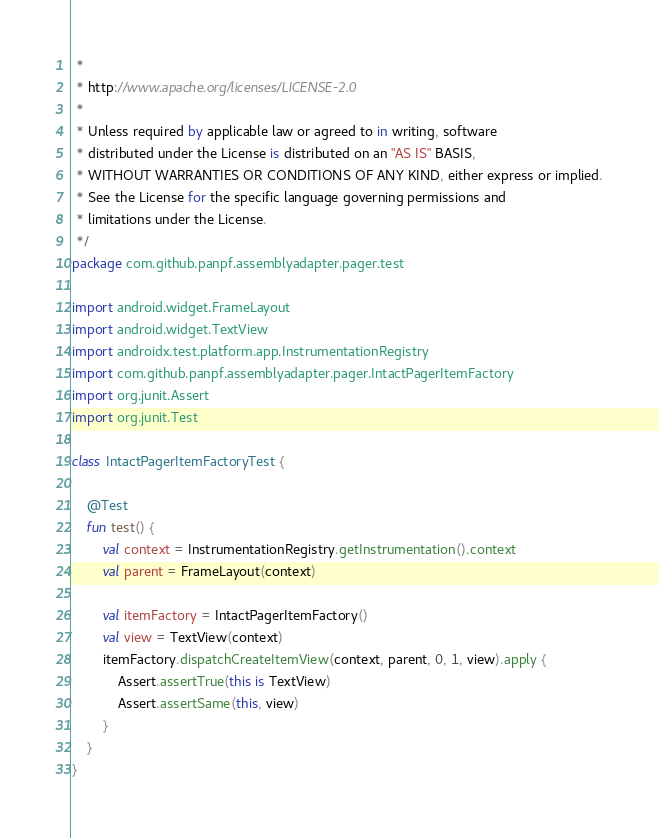Convert code to text. <code><loc_0><loc_0><loc_500><loc_500><_Kotlin_> *
 * http://www.apache.org/licenses/LICENSE-2.0
 *
 * Unless required by applicable law or agreed to in writing, software
 * distributed under the License is distributed on an "AS IS" BASIS,
 * WITHOUT WARRANTIES OR CONDITIONS OF ANY KIND, either express or implied.
 * See the License for the specific language governing permissions and
 * limitations under the License.
 */
package com.github.panpf.assemblyadapter.pager.test

import android.widget.FrameLayout
import android.widget.TextView
import androidx.test.platform.app.InstrumentationRegistry
import com.github.panpf.assemblyadapter.pager.IntactPagerItemFactory
import org.junit.Assert
import org.junit.Test

class IntactPagerItemFactoryTest {

    @Test
    fun test() {
        val context = InstrumentationRegistry.getInstrumentation().context
        val parent = FrameLayout(context)

        val itemFactory = IntactPagerItemFactory()
        val view = TextView(context)
        itemFactory.dispatchCreateItemView(context, parent, 0, 1, view).apply {
            Assert.assertTrue(this is TextView)
            Assert.assertSame(this, view)
        }
    }
}</code> 